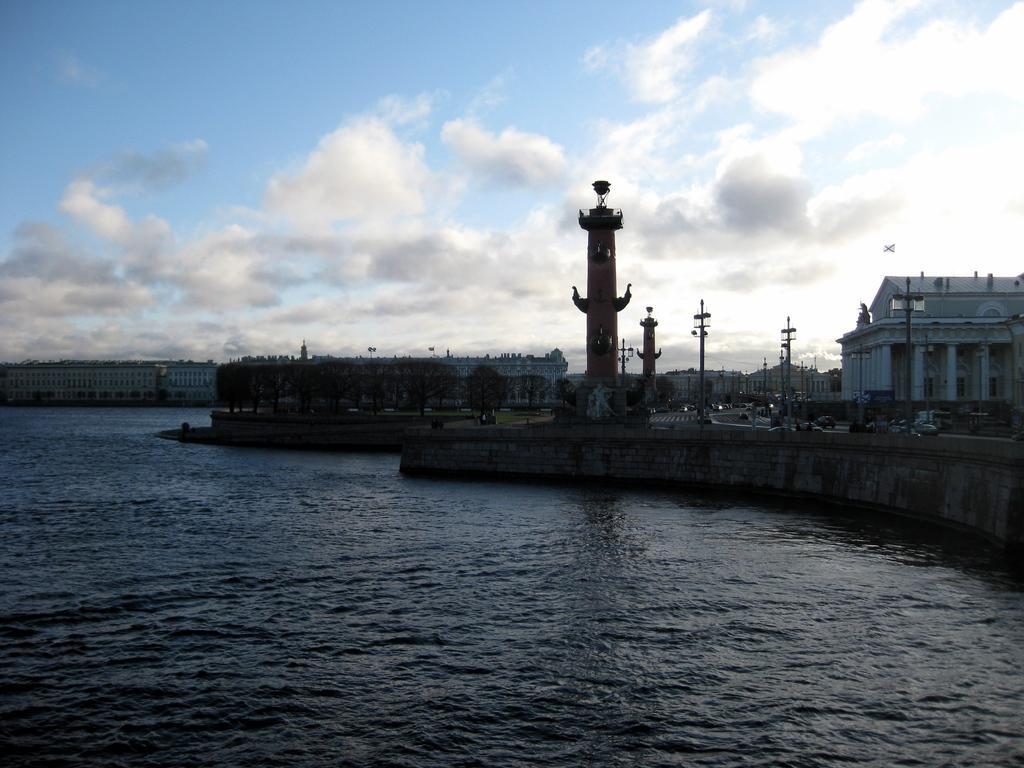How would you summarize this image in a sentence or two? In this picture I can observe a river. In the middle of the picture I can observe a tower. On the right side there is a building. In the background there are some clouds in the sky. 